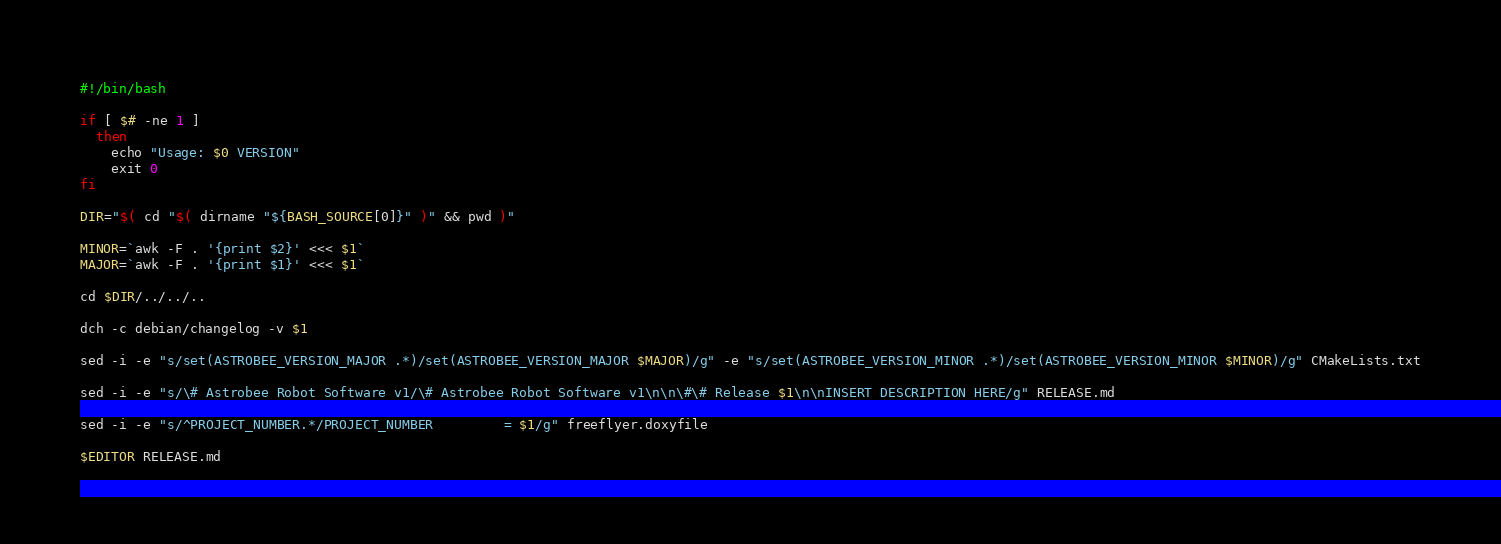Convert code to text. <code><loc_0><loc_0><loc_500><loc_500><_Bash_>#!/bin/bash

if [ $# -ne 1 ]
  then
    echo "Usage: $0 VERSION"
    exit 0
fi

DIR="$( cd "$( dirname "${BASH_SOURCE[0]}" )" && pwd )"

MINOR=`awk -F . '{print $2}' <<< $1`
MAJOR=`awk -F . '{print $1}' <<< $1`

cd $DIR/../../..

dch -c debian/changelog -v $1

sed -i -e "s/set(ASTROBEE_VERSION_MAJOR .*)/set(ASTROBEE_VERSION_MAJOR $MAJOR)/g" -e "s/set(ASTROBEE_VERSION_MINOR .*)/set(ASTROBEE_VERSION_MINOR $MINOR)/g" CMakeLists.txt

sed -i -e "s/\# Astrobee Robot Software v1/\# Astrobee Robot Software v1\n\n\#\# Release $1\n\nINSERT DESCRIPTION HERE/g" RELEASE.md

sed -i -e "s/^PROJECT_NUMBER.*/PROJECT_NUMBER         = $1/g" freeflyer.doxyfile

$EDITOR RELEASE.md
</code> 